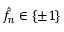Convert formula to latex. <formula><loc_0><loc_0><loc_500><loc_500>\hat { f } _ { n } \in \left \{ \pm 1 \right \}</formula> 